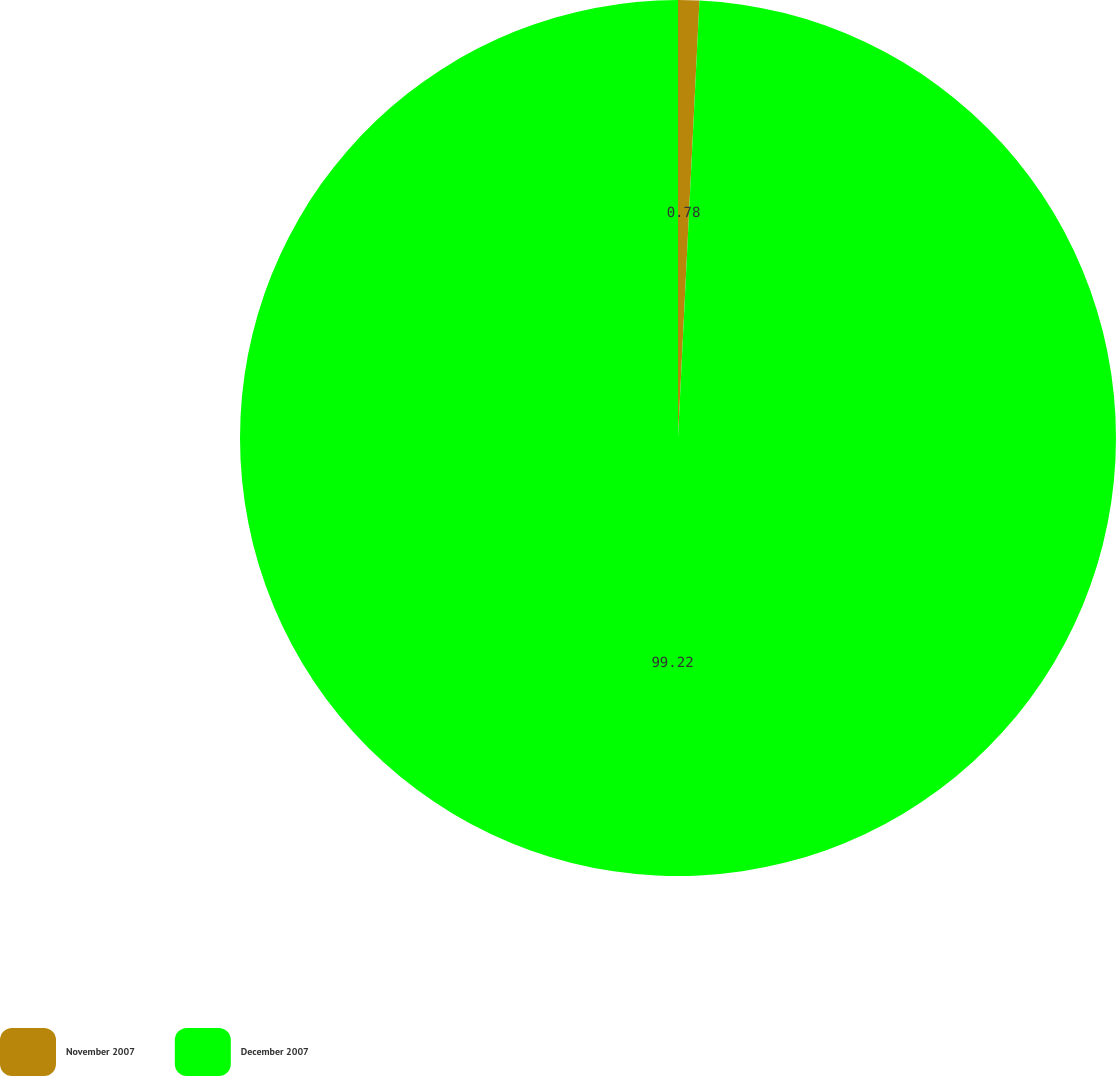Convert chart. <chart><loc_0><loc_0><loc_500><loc_500><pie_chart><fcel>November 2007<fcel>December 2007<nl><fcel>0.78%<fcel>99.22%<nl></chart> 